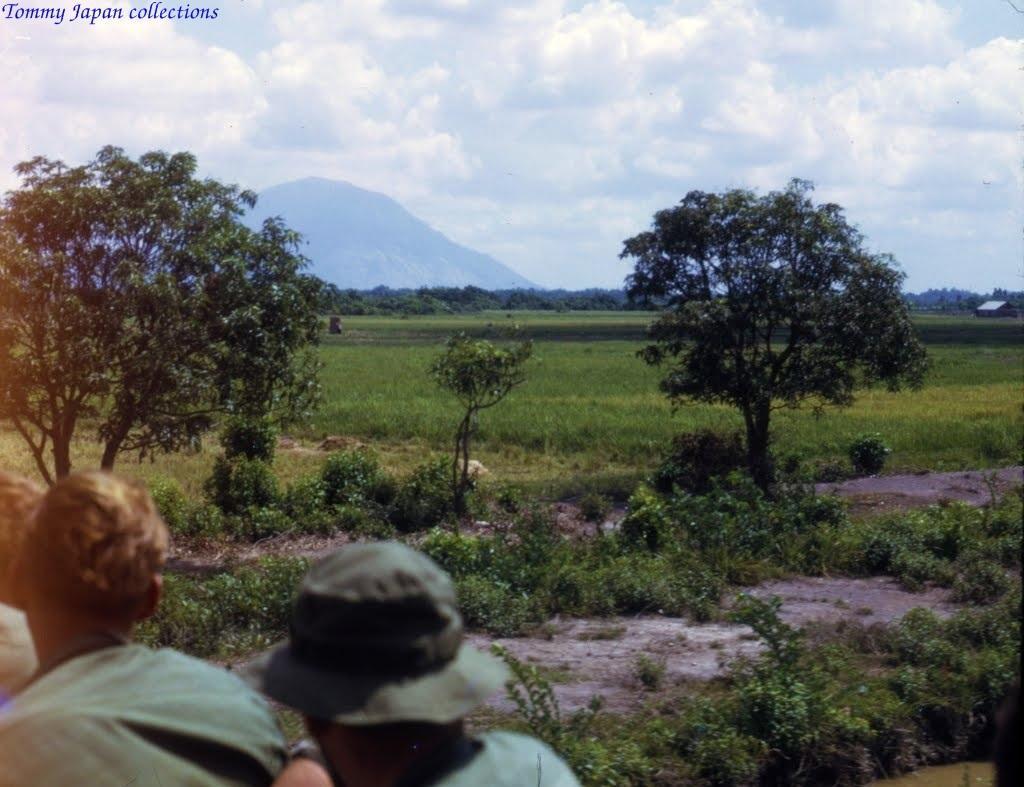Could you give a brief overview of what you see in this image? In this image we can see sky with clouds, hills, trees, grass, shrubs, ground and persons. 